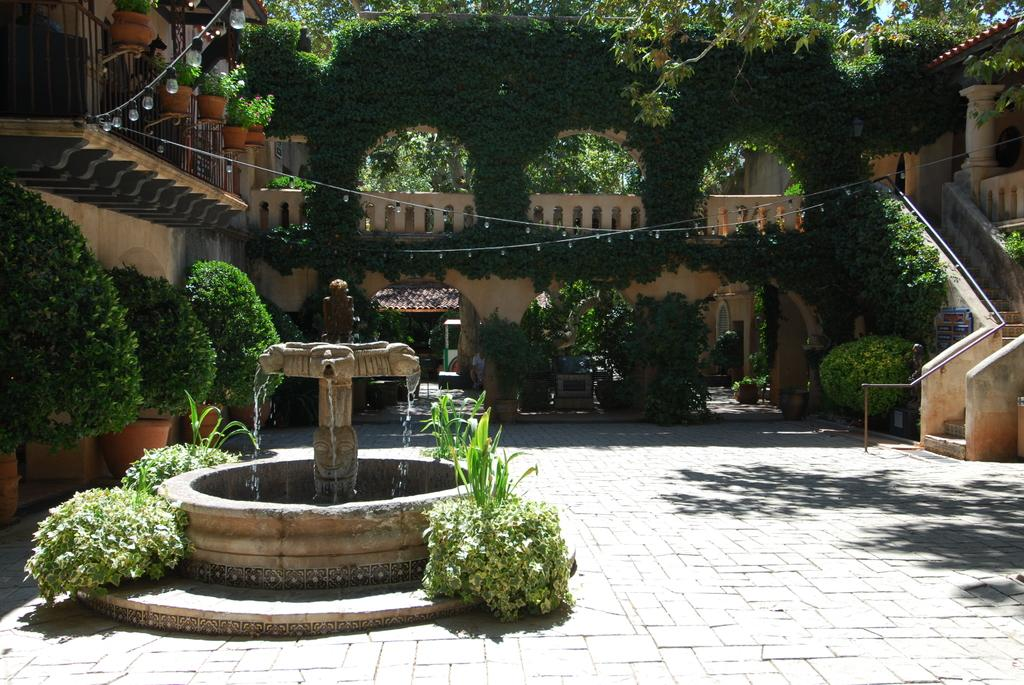What type of natural elements can be seen in the image? There are trees in the image. What type of man-made structures are present in the image? There are buildings in the image. What type of vegetation can be seen in the image? There are plants in the image. What type of water feature is present in the image? There is a water fountain in the image. What type of architectural feature is present in the image? There are stairs in the image. What type of support structures are present in the image? There are posts in the image. What type of illumination is present in the image? There are lights in the image. How many matches are visible in the image? There are no matches present in the image. What type of wrist accessory is worn by the trees in the image? There are no wrist accessories present in the image, as trees do not have wrists. 